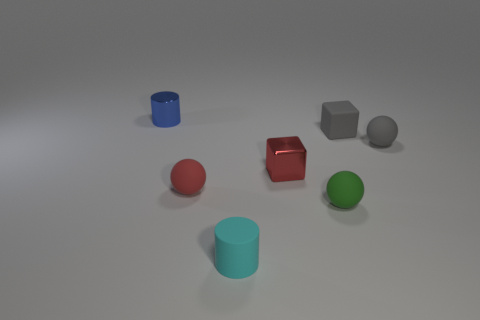Do the metal block and the sphere on the left side of the tiny cyan rubber object have the same color?
Make the answer very short. Yes. There is a ball that is behind the metallic thing that is in front of the small sphere to the right of the small gray matte cube; what size is it?
Make the answer very short. Small. There is a blue shiny cylinder; does it have the same size as the object in front of the green rubber sphere?
Provide a succinct answer. Yes. Are there any gray cylinders of the same size as the red matte ball?
Offer a very short reply. No. What number of things are either small yellow matte blocks or gray objects?
Offer a terse response. 2. Do the red thing behind the tiny red rubber object and the shiny thing behind the small metallic cube have the same size?
Offer a terse response. Yes. Is there a matte thing of the same shape as the red shiny object?
Offer a terse response. Yes. Are there fewer red matte spheres that are to the right of the red metallic thing than blue metallic balls?
Keep it short and to the point. No. Does the green object have the same shape as the tiny red rubber object?
Give a very brief answer. Yes. There is a metal object that is to the left of the small cyan thing; how big is it?
Offer a terse response. Small. 